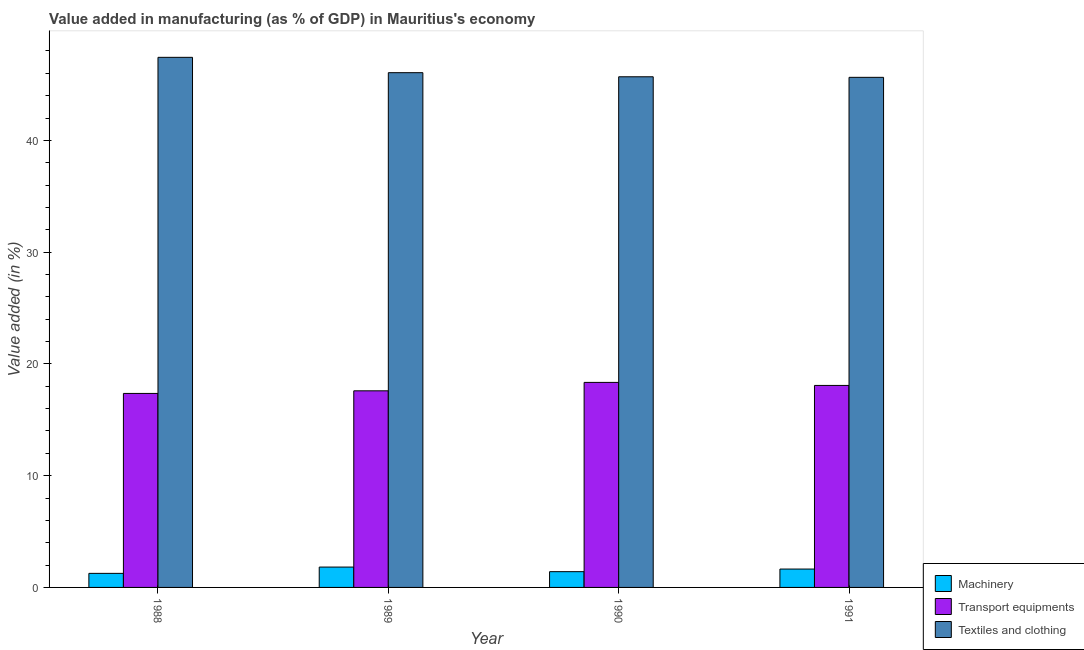How many groups of bars are there?
Provide a succinct answer. 4. Are the number of bars per tick equal to the number of legend labels?
Make the answer very short. Yes. Are the number of bars on each tick of the X-axis equal?
Ensure brevity in your answer.  Yes. How many bars are there on the 3rd tick from the left?
Provide a succinct answer. 3. What is the label of the 3rd group of bars from the left?
Offer a terse response. 1990. In how many cases, is the number of bars for a given year not equal to the number of legend labels?
Make the answer very short. 0. What is the value added in manufacturing machinery in 1991?
Offer a very short reply. 1.64. Across all years, what is the maximum value added in manufacturing machinery?
Provide a short and direct response. 1.82. Across all years, what is the minimum value added in manufacturing transport equipments?
Provide a succinct answer. 17.36. What is the total value added in manufacturing transport equipments in the graph?
Offer a terse response. 71.37. What is the difference between the value added in manufacturing textile and clothing in 1990 and that in 1991?
Offer a very short reply. 0.05. What is the difference between the value added in manufacturing machinery in 1989 and the value added in manufacturing textile and clothing in 1990?
Provide a short and direct response. 0.41. What is the average value added in manufacturing machinery per year?
Make the answer very short. 1.53. What is the ratio of the value added in manufacturing transport equipments in 1988 to that in 1990?
Offer a terse response. 0.95. Is the value added in manufacturing textile and clothing in 1990 less than that in 1991?
Provide a short and direct response. No. What is the difference between the highest and the second highest value added in manufacturing machinery?
Make the answer very short. 0.18. What is the difference between the highest and the lowest value added in manufacturing transport equipments?
Provide a short and direct response. 0.99. In how many years, is the value added in manufacturing transport equipments greater than the average value added in manufacturing transport equipments taken over all years?
Offer a very short reply. 2. Is the sum of the value added in manufacturing machinery in 1988 and 1991 greater than the maximum value added in manufacturing textile and clothing across all years?
Offer a very short reply. Yes. What does the 2nd bar from the left in 1990 represents?
Ensure brevity in your answer.  Transport equipments. What does the 3rd bar from the right in 1988 represents?
Ensure brevity in your answer.  Machinery. Is it the case that in every year, the sum of the value added in manufacturing machinery and value added in manufacturing transport equipments is greater than the value added in manufacturing textile and clothing?
Your response must be concise. No. What is the difference between two consecutive major ticks on the Y-axis?
Make the answer very short. 10. Where does the legend appear in the graph?
Keep it short and to the point. Bottom right. How are the legend labels stacked?
Your response must be concise. Vertical. What is the title of the graph?
Make the answer very short. Value added in manufacturing (as % of GDP) in Mauritius's economy. What is the label or title of the X-axis?
Provide a succinct answer. Year. What is the label or title of the Y-axis?
Offer a very short reply. Value added (in %). What is the Value added (in %) in Machinery in 1988?
Your answer should be compact. 1.26. What is the Value added (in %) in Transport equipments in 1988?
Your response must be concise. 17.36. What is the Value added (in %) of Textiles and clothing in 1988?
Keep it short and to the point. 47.43. What is the Value added (in %) in Machinery in 1989?
Give a very brief answer. 1.82. What is the Value added (in %) of Transport equipments in 1989?
Give a very brief answer. 17.59. What is the Value added (in %) in Textiles and clothing in 1989?
Your answer should be very brief. 46.06. What is the Value added (in %) of Machinery in 1990?
Make the answer very short. 1.41. What is the Value added (in %) in Transport equipments in 1990?
Your answer should be compact. 18.35. What is the Value added (in %) in Textiles and clothing in 1990?
Provide a short and direct response. 45.69. What is the Value added (in %) in Machinery in 1991?
Ensure brevity in your answer.  1.64. What is the Value added (in %) in Transport equipments in 1991?
Your response must be concise. 18.07. What is the Value added (in %) in Textiles and clothing in 1991?
Provide a short and direct response. 45.64. Across all years, what is the maximum Value added (in %) in Machinery?
Give a very brief answer. 1.82. Across all years, what is the maximum Value added (in %) of Transport equipments?
Give a very brief answer. 18.35. Across all years, what is the maximum Value added (in %) of Textiles and clothing?
Provide a short and direct response. 47.43. Across all years, what is the minimum Value added (in %) in Machinery?
Offer a terse response. 1.26. Across all years, what is the minimum Value added (in %) in Transport equipments?
Provide a short and direct response. 17.36. Across all years, what is the minimum Value added (in %) of Textiles and clothing?
Provide a succinct answer. 45.64. What is the total Value added (in %) of Machinery in the graph?
Your response must be concise. 6.13. What is the total Value added (in %) in Transport equipments in the graph?
Make the answer very short. 71.37. What is the total Value added (in %) in Textiles and clothing in the graph?
Offer a very short reply. 184.82. What is the difference between the Value added (in %) in Machinery in 1988 and that in 1989?
Offer a very short reply. -0.56. What is the difference between the Value added (in %) of Transport equipments in 1988 and that in 1989?
Keep it short and to the point. -0.23. What is the difference between the Value added (in %) in Textiles and clothing in 1988 and that in 1989?
Provide a short and direct response. 1.37. What is the difference between the Value added (in %) of Machinery in 1988 and that in 1990?
Provide a succinct answer. -0.15. What is the difference between the Value added (in %) in Transport equipments in 1988 and that in 1990?
Offer a very short reply. -0.99. What is the difference between the Value added (in %) in Textiles and clothing in 1988 and that in 1990?
Give a very brief answer. 1.74. What is the difference between the Value added (in %) in Machinery in 1988 and that in 1991?
Keep it short and to the point. -0.39. What is the difference between the Value added (in %) of Transport equipments in 1988 and that in 1991?
Ensure brevity in your answer.  -0.71. What is the difference between the Value added (in %) of Textiles and clothing in 1988 and that in 1991?
Make the answer very short. 1.79. What is the difference between the Value added (in %) in Machinery in 1989 and that in 1990?
Your answer should be very brief. 0.41. What is the difference between the Value added (in %) of Transport equipments in 1989 and that in 1990?
Make the answer very short. -0.75. What is the difference between the Value added (in %) of Textiles and clothing in 1989 and that in 1990?
Keep it short and to the point. 0.37. What is the difference between the Value added (in %) of Machinery in 1989 and that in 1991?
Your answer should be very brief. 0.18. What is the difference between the Value added (in %) of Transport equipments in 1989 and that in 1991?
Give a very brief answer. -0.48. What is the difference between the Value added (in %) of Textiles and clothing in 1989 and that in 1991?
Your answer should be compact. 0.42. What is the difference between the Value added (in %) in Machinery in 1990 and that in 1991?
Your response must be concise. -0.23. What is the difference between the Value added (in %) of Transport equipments in 1990 and that in 1991?
Offer a very short reply. 0.27. What is the difference between the Value added (in %) of Textiles and clothing in 1990 and that in 1991?
Make the answer very short. 0.05. What is the difference between the Value added (in %) in Machinery in 1988 and the Value added (in %) in Transport equipments in 1989?
Your answer should be compact. -16.33. What is the difference between the Value added (in %) in Machinery in 1988 and the Value added (in %) in Textiles and clothing in 1989?
Your response must be concise. -44.8. What is the difference between the Value added (in %) of Transport equipments in 1988 and the Value added (in %) of Textiles and clothing in 1989?
Give a very brief answer. -28.7. What is the difference between the Value added (in %) in Machinery in 1988 and the Value added (in %) in Transport equipments in 1990?
Give a very brief answer. -17.09. What is the difference between the Value added (in %) of Machinery in 1988 and the Value added (in %) of Textiles and clothing in 1990?
Offer a very short reply. -44.43. What is the difference between the Value added (in %) of Transport equipments in 1988 and the Value added (in %) of Textiles and clothing in 1990?
Give a very brief answer. -28.33. What is the difference between the Value added (in %) in Machinery in 1988 and the Value added (in %) in Transport equipments in 1991?
Your answer should be very brief. -16.81. What is the difference between the Value added (in %) of Machinery in 1988 and the Value added (in %) of Textiles and clothing in 1991?
Provide a succinct answer. -44.38. What is the difference between the Value added (in %) in Transport equipments in 1988 and the Value added (in %) in Textiles and clothing in 1991?
Your answer should be very brief. -28.28. What is the difference between the Value added (in %) in Machinery in 1989 and the Value added (in %) in Transport equipments in 1990?
Provide a succinct answer. -16.52. What is the difference between the Value added (in %) in Machinery in 1989 and the Value added (in %) in Textiles and clothing in 1990?
Offer a terse response. -43.87. What is the difference between the Value added (in %) of Transport equipments in 1989 and the Value added (in %) of Textiles and clothing in 1990?
Keep it short and to the point. -28.1. What is the difference between the Value added (in %) of Machinery in 1989 and the Value added (in %) of Transport equipments in 1991?
Ensure brevity in your answer.  -16.25. What is the difference between the Value added (in %) of Machinery in 1989 and the Value added (in %) of Textiles and clothing in 1991?
Keep it short and to the point. -43.82. What is the difference between the Value added (in %) in Transport equipments in 1989 and the Value added (in %) in Textiles and clothing in 1991?
Make the answer very short. -28.05. What is the difference between the Value added (in %) in Machinery in 1990 and the Value added (in %) in Transport equipments in 1991?
Your answer should be very brief. -16.66. What is the difference between the Value added (in %) in Machinery in 1990 and the Value added (in %) in Textiles and clothing in 1991?
Your answer should be very brief. -44.23. What is the difference between the Value added (in %) of Transport equipments in 1990 and the Value added (in %) of Textiles and clothing in 1991?
Keep it short and to the point. -27.29. What is the average Value added (in %) in Machinery per year?
Provide a short and direct response. 1.53. What is the average Value added (in %) of Transport equipments per year?
Keep it short and to the point. 17.84. What is the average Value added (in %) of Textiles and clothing per year?
Your response must be concise. 46.2. In the year 1988, what is the difference between the Value added (in %) in Machinery and Value added (in %) in Transport equipments?
Ensure brevity in your answer.  -16.1. In the year 1988, what is the difference between the Value added (in %) in Machinery and Value added (in %) in Textiles and clothing?
Keep it short and to the point. -46.17. In the year 1988, what is the difference between the Value added (in %) in Transport equipments and Value added (in %) in Textiles and clothing?
Your response must be concise. -30.07. In the year 1989, what is the difference between the Value added (in %) in Machinery and Value added (in %) in Transport equipments?
Give a very brief answer. -15.77. In the year 1989, what is the difference between the Value added (in %) of Machinery and Value added (in %) of Textiles and clothing?
Your response must be concise. -44.24. In the year 1989, what is the difference between the Value added (in %) in Transport equipments and Value added (in %) in Textiles and clothing?
Provide a succinct answer. -28.46. In the year 1990, what is the difference between the Value added (in %) of Machinery and Value added (in %) of Transport equipments?
Give a very brief answer. -16.93. In the year 1990, what is the difference between the Value added (in %) of Machinery and Value added (in %) of Textiles and clothing?
Ensure brevity in your answer.  -44.28. In the year 1990, what is the difference between the Value added (in %) in Transport equipments and Value added (in %) in Textiles and clothing?
Offer a terse response. -27.34. In the year 1991, what is the difference between the Value added (in %) of Machinery and Value added (in %) of Transport equipments?
Your answer should be very brief. -16.43. In the year 1991, what is the difference between the Value added (in %) of Machinery and Value added (in %) of Textiles and clothing?
Ensure brevity in your answer.  -44. In the year 1991, what is the difference between the Value added (in %) in Transport equipments and Value added (in %) in Textiles and clothing?
Offer a very short reply. -27.57. What is the ratio of the Value added (in %) in Machinery in 1988 to that in 1989?
Your answer should be very brief. 0.69. What is the ratio of the Value added (in %) in Transport equipments in 1988 to that in 1989?
Provide a short and direct response. 0.99. What is the ratio of the Value added (in %) in Textiles and clothing in 1988 to that in 1989?
Provide a short and direct response. 1.03. What is the ratio of the Value added (in %) in Machinery in 1988 to that in 1990?
Ensure brevity in your answer.  0.89. What is the ratio of the Value added (in %) in Transport equipments in 1988 to that in 1990?
Keep it short and to the point. 0.95. What is the ratio of the Value added (in %) in Textiles and clothing in 1988 to that in 1990?
Offer a terse response. 1.04. What is the ratio of the Value added (in %) in Machinery in 1988 to that in 1991?
Make the answer very short. 0.77. What is the ratio of the Value added (in %) in Transport equipments in 1988 to that in 1991?
Make the answer very short. 0.96. What is the ratio of the Value added (in %) in Textiles and clothing in 1988 to that in 1991?
Keep it short and to the point. 1.04. What is the ratio of the Value added (in %) in Machinery in 1989 to that in 1990?
Provide a succinct answer. 1.29. What is the ratio of the Value added (in %) in Transport equipments in 1989 to that in 1990?
Your answer should be very brief. 0.96. What is the ratio of the Value added (in %) of Machinery in 1989 to that in 1991?
Ensure brevity in your answer.  1.11. What is the ratio of the Value added (in %) in Transport equipments in 1989 to that in 1991?
Keep it short and to the point. 0.97. What is the ratio of the Value added (in %) in Textiles and clothing in 1989 to that in 1991?
Provide a short and direct response. 1.01. What is the ratio of the Value added (in %) of Machinery in 1990 to that in 1991?
Your response must be concise. 0.86. What is the ratio of the Value added (in %) of Transport equipments in 1990 to that in 1991?
Keep it short and to the point. 1.02. What is the ratio of the Value added (in %) of Textiles and clothing in 1990 to that in 1991?
Offer a terse response. 1. What is the difference between the highest and the second highest Value added (in %) of Machinery?
Offer a terse response. 0.18. What is the difference between the highest and the second highest Value added (in %) in Transport equipments?
Make the answer very short. 0.27. What is the difference between the highest and the second highest Value added (in %) in Textiles and clothing?
Your answer should be very brief. 1.37. What is the difference between the highest and the lowest Value added (in %) of Machinery?
Your answer should be compact. 0.56. What is the difference between the highest and the lowest Value added (in %) in Transport equipments?
Your response must be concise. 0.99. What is the difference between the highest and the lowest Value added (in %) of Textiles and clothing?
Make the answer very short. 1.79. 